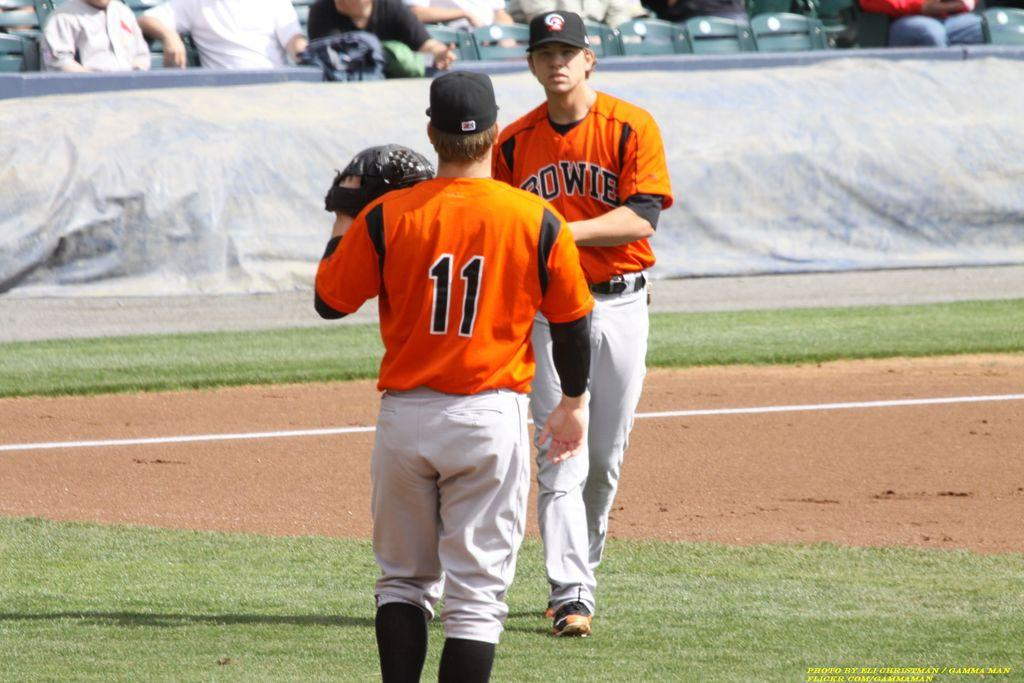<image>
Give a short and clear explanation of the subsequent image. Player number 11 is walking towards another player on his team. 